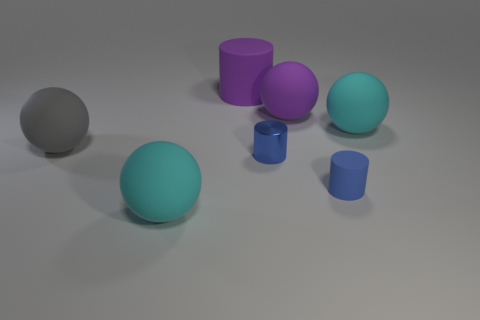Is the number of blue cylinders that are behind the blue matte cylinder less than the number of big cylinders?
Offer a terse response. No. Is there any other thing that is the same shape as the gray thing?
Keep it short and to the point. Yes. There is another large object that is the same shape as the blue rubber thing; what color is it?
Keep it short and to the point. Purple. There is a cyan rubber thing that is behind the gray thing; is it the same size as the large purple matte sphere?
Make the answer very short. Yes. How big is the cyan matte object that is in front of the blue cylinder to the left of the large purple ball?
Give a very brief answer. Large. Are the large gray ball and the small thing that is left of the small rubber cylinder made of the same material?
Ensure brevity in your answer.  No. Are there fewer objects in front of the large gray sphere than tiny blue matte cylinders behind the blue shiny thing?
Your answer should be compact. No. What is the color of the tiny object that is made of the same material as the large gray thing?
Make the answer very short. Blue. There is a big cyan rubber sphere that is to the right of the large cylinder; are there any big cyan spheres that are on the right side of it?
Ensure brevity in your answer.  No. What color is the matte cylinder that is the same size as the gray matte thing?
Provide a succinct answer. Purple. 